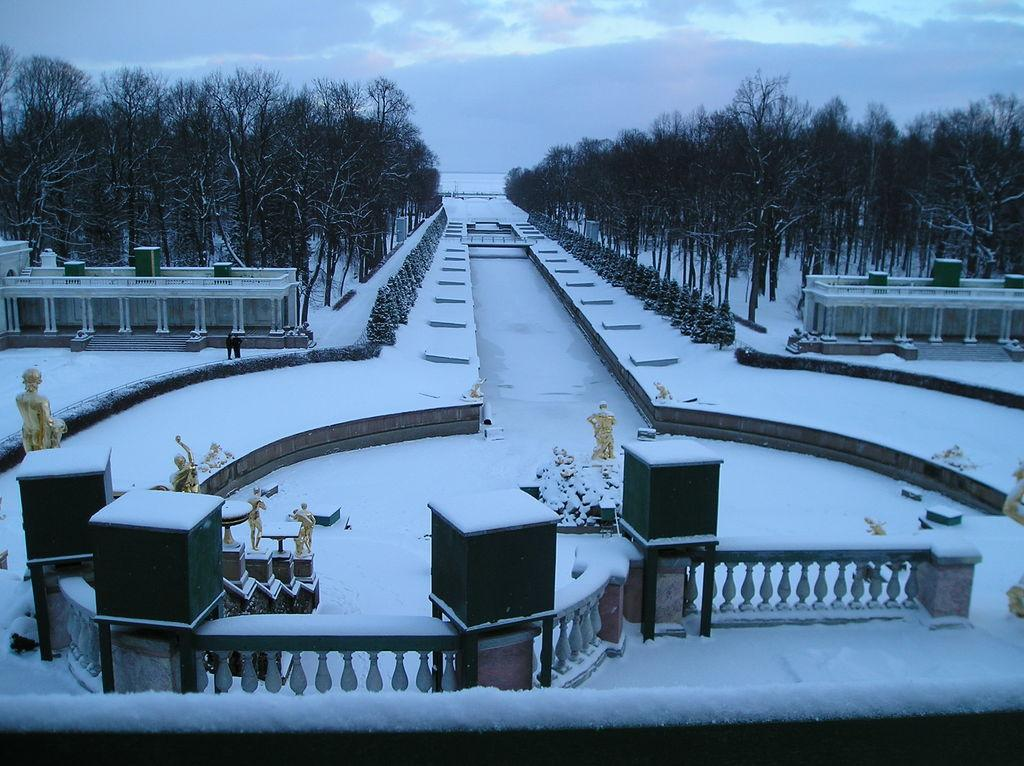What can be seen at the bottom of the image? There is snow at the bottom of the image. What is located in the middle of the image? There are statues in the middle of the image. What type of vegetation is on either side of the image? There are trees on either side of the image. What is visible at the top of the image? The sky is visible at the top of the image. What type of worm can be seen crawling on the side of the railing in the image? There are no worms present in the image; the focus is on the snow, statues, trees, and sky. 